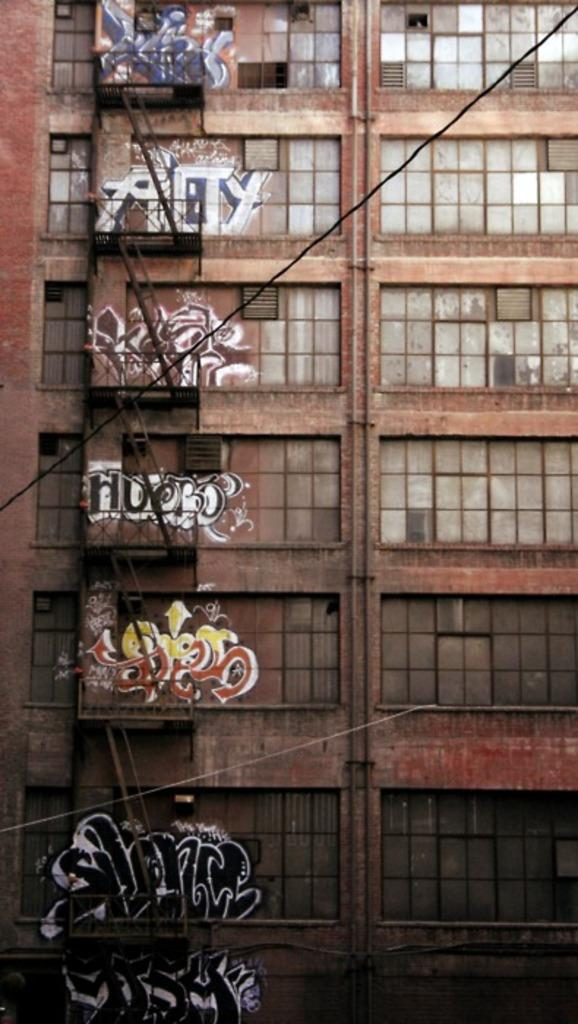What is the main structure visible in the image? There is a building in the image. What decorative elements can be seen on the building? There are paintings on the building. What type of bottle is being used for pleasure in the image? There is no bottle or reference to pleasure in the image; it features a building with paintings on it. 